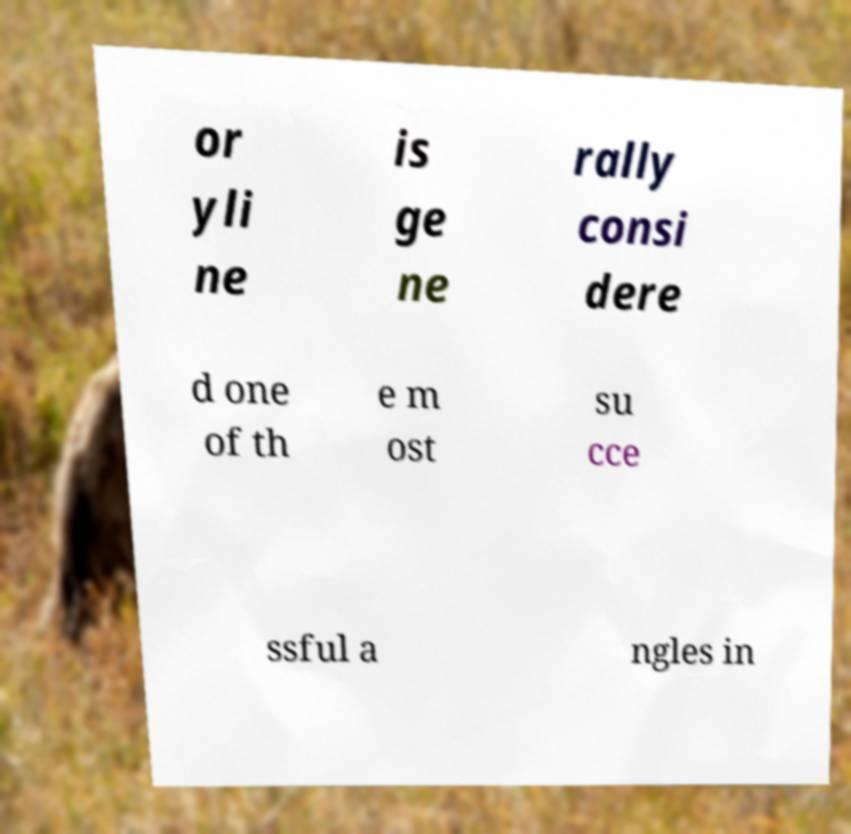Please identify and transcribe the text found in this image. or yli ne is ge ne rally consi dere d one of th e m ost su cce ssful a ngles in 